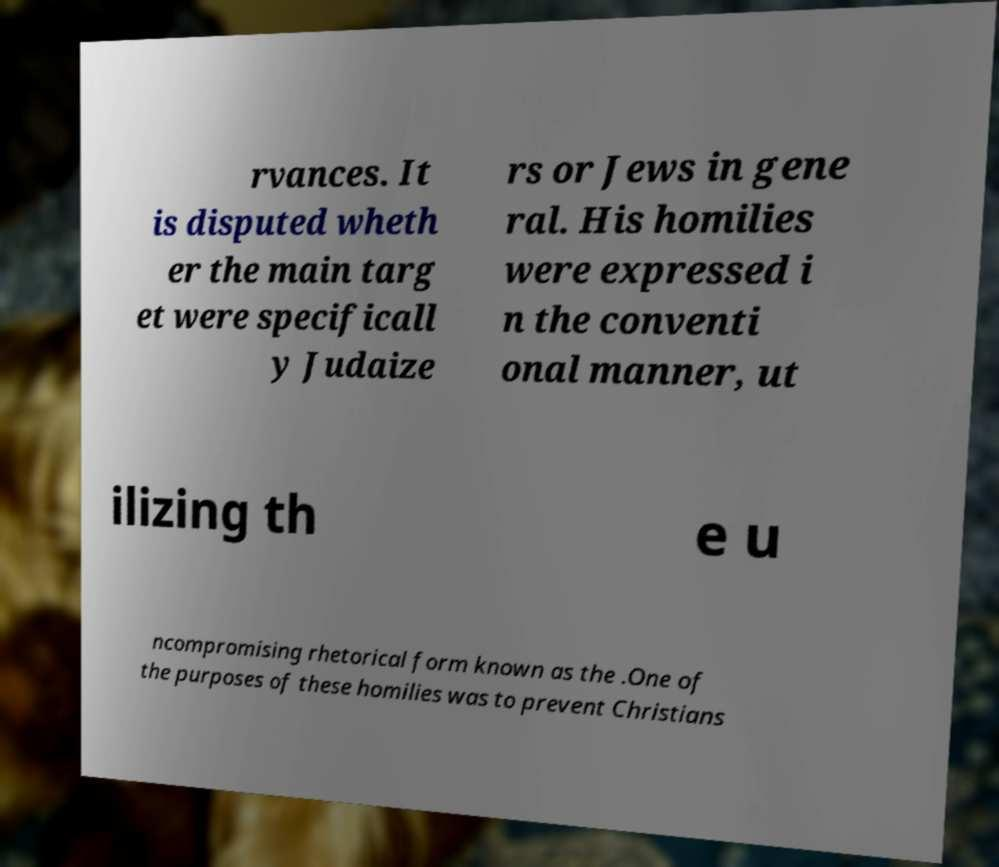Could you extract and type out the text from this image? rvances. It is disputed wheth er the main targ et were specificall y Judaize rs or Jews in gene ral. His homilies were expressed i n the conventi onal manner, ut ilizing th e u ncompromising rhetorical form known as the .One of the purposes of these homilies was to prevent Christians 